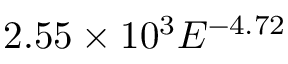Convert formula to latex. <formula><loc_0><loc_0><loc_500><loc_500>2 . 5 5 \times 1 0 ^ { 3 } E ^ { - 4 . 7 2 }</formula> 